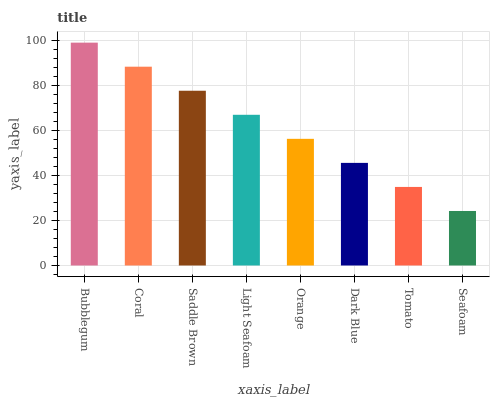Is Seafoam the minimum?
Answer yes or no. Yes. Is Bubblegum the maximum?
Answer yes or no. Yes. Is Coral the minimum?
Answer yes or no. No. Is Coral the maximum?
Answer yes or no. No. Is Bubblegum greater than Coral?
Answer yes or no. Yes. Is Coral less than Bubblegum?
Answer yes or no. Yes. Is Coral greater than Bubblegum?
Answer yes or no. No. Is Bubblegum less than Coral?
Answer yes or no. No. Is Light Seafoam the high median?
Answer yes or no. Yes. Is Orange the low median?
Answer yes or no. Yes. Is Bubblegum the high median?
Answer yes or no. No. Is Light Seafoam the low median?
Answer yes or no. No. 